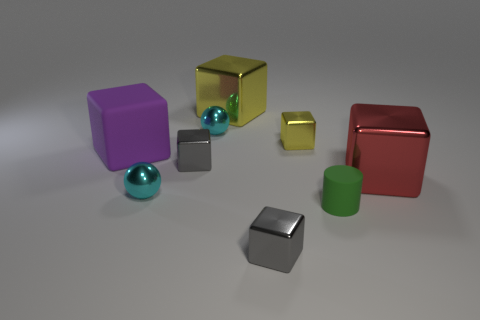Is the number of big things less than the number of tiny objects?
Provide a short and direct response. Yes. What is the shape of the thing that is right of the tiny green thing that is in front of the cyan shiny object that is in front of the large purple rubber block?
Your answer should be very brief. Cube. How many objects are objects that are in front of the big yellow thing or small shiny spheres in front of the purple thing?
Make the answer very short. 8. Are there any tiny cyan balls in front of the large purple matte cube?
Offer a terse response. Yes. What number of objects are either metallic cubes that are left of the red thing or tiny gray cylinders?
Provide a short and direct response. 4. What number of red things are either large matte things or shiny objects?
Make the answer very short. 1. Is the number of cubes on the left side of the large purple rubber cube less than the number of small yellow metal things?
Provide a short and direct response. Yes. There is a ball in front of the large metallic cube that is in front of the tiny metallic cube that is behind the large purple rubber cube; what color is it?
Your answer should be compact. Cyan. There is a rubber thing that is the same shape as the red shiny object; what is its size?
Ensure brevity in your answer.  Large. Is the number of big yellow objects that are to the right of the big yellow cube less than the number of tiny gray things in front of the purple cube?
Your answer should be very brief. Yes. 